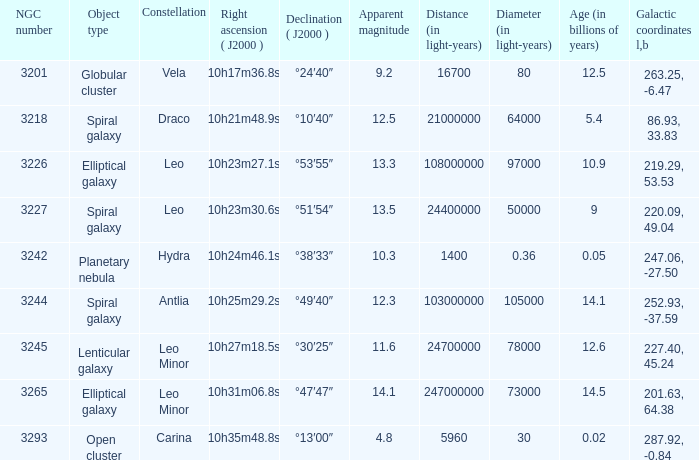What is the sum of NGC numbers for Constellation vela? 3201.0. 